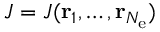<formula> <loc_0><loc_0><loc_500><loc_500>J = J ( { r } _ { 1 } , \dots , { r } _ { N _ { e } } )</formula> 